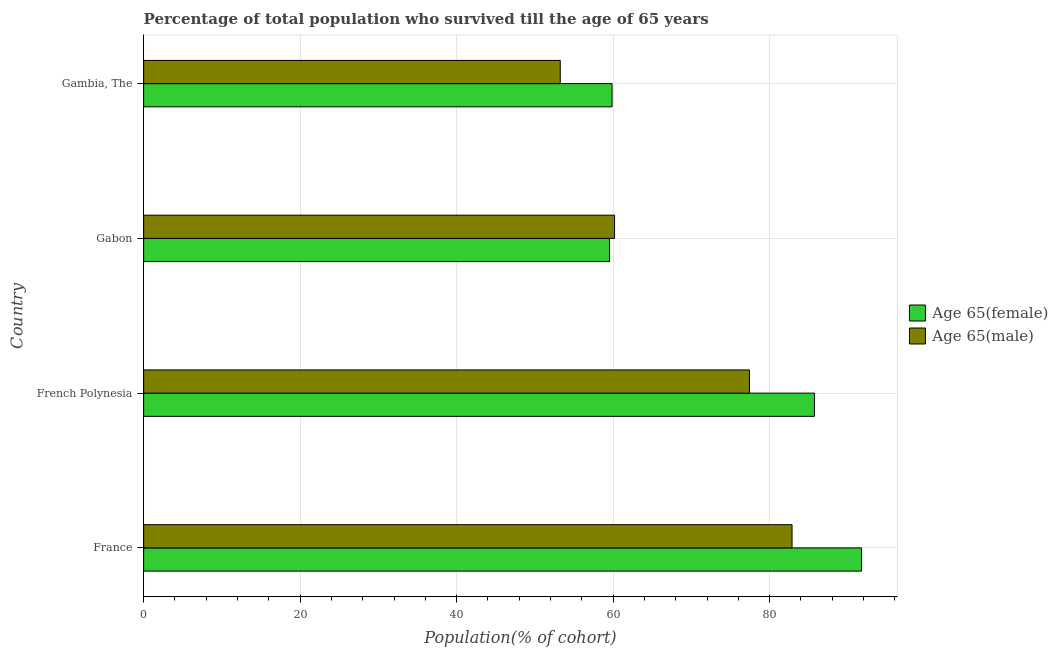How many different coloured bars are there?
Give a very brief answer. 2. How many groups of bars are there?
Your response must be concise. 4. Are the number of bars per tick equal to the number of legend labels?
Offer a terse response. Yes. Are the number of bars on each tick of the Y-axis equal?
Give a very brief answer. Yes. How many bars are there on the 3rd tick from the bottom?
Ensure brevity in your answer.  2. What is the label of the 4th group of bars from the top?
Provide a succinct answer. France. What is the percentage of female population who survived till age of 65 in France?
Make the answer very short. 91.74. Across all countries, what is the maximum percentage of male population who survived till age of 65?
Keep it short and to the point. 82.86. Across all countries, what is the minimum percentage of female population who survived till age of 65?
Provide a short and direct response. 59.54. In which country was the percentage of female population who survived till age of 65 minimum?
Provide a short and direct response. Gabon. What is the total percentage of male population who survived till age of 65 in the graph?
Offer a terse response. 273.71. What is the difference between the percentage of female population who survived till age of 65 in France and that in French Polynesia?
Offer a very short reply. 6.01. What is the difference between the percentage of female population who survived till age of 65 in Gabon and the percentage of male population who survived till age of 65 in France?
Offer a terse response. -23.33. What is the average percentage of male population who survived till age of 65 per country?
Your response must be concise. 68.43. What is the difference between the percentage of male population who survived till age of 65 and percentage of female population who survived till age of 65 in French Polynesia?
Give a very brief answer. -8.31. What is the ratio of the percentage of female population who survived till age of 65 in French Polynesia to that in Gabon?
Give a very brief answer. 1.44. Is the percentage of male population who survived till age of 65 in France less than that in French Polynesia?
Your response must be concise. No. What is the difference between the highest and the second highest percentage of female population who survived till age of 65?
Your answer should be very brief. 6.01. What is the difference between the highest and the lowest percentage of male population who survived till age of 65?
Give a very brief answer. 29.62. In how many countries, is the percentage of male population who survived till age of 65 greater than the average percentage of male population who survived till age of 65 taken over all countries?
Provide a short and direct response. 2. What does the 2nd bar from the top in Gabon represents?
Ensure brevity in your answer.  Age 65(female). What does the 2nd bar from the bottom in Gambia, The represents?
Offer a terse response. Age 65(male). Are all the bars in the graph horizontal?
Offer a very short reply. Yes. How many countries are there in the graph?
Give a very brief answer. 4. What is the difference between two consecutive major ticks on the X-axis?
Your response must be concise. 20. Are the values on the major ticks of X-axis written in scientific E-notation?
Offer a very short reply. No. Does the graph contain any zero values?
Provide a short and direct response. No. Does the graph contain grids?
Give a very brief answer. Yes. How many legend labels are there?
Offer a terse response. 2. What is the title of the graph?
Give a very brief answer. Percentage of total population who survived till the age of 65 years. Does "Old" appear as one of the legend labels in the graph?
Provide a short and direct response. No. What is the label or title of the X-axis?
Give a very brief answer. Population(% of cohort). What is the Population(% of cohort) in Age 65(female) in France?
Provide a short and direct response. 91.74. What is the Population(% of cohort) of Age 65(male) in France?
Your answer should be very brief. 82.86. What is the Population(% of cohort) in Age 65(female) in French Polynesia?
Keep it short and to the point. 85.73. What is the Population(% of cohort) in Age 65(male) in French Polynesia?
Ensure brevity in your answer.  77.42. What is the Population(% of cohort) of Age 65(female) in Gabon?
Provide a short and direct response. 59.54. What is the Population(% of cohort) of Age 65(male) in Gabon?
Provide a succinct answer. 60.18. What is the Population(% of cohort) of Age 65(female) in Gambia, The?
Provide a succinct answer. 59.86. What is the Population(% of cohort) of Age 65(male) in Gambia, The?
Make the answer very short. 53.24. Across all countries, what is the maximum Population(% of cohort) in Age 65(female)?
Offer a very short reply. 91.74. Across all countries, what is the maximum Population(% of cohort) in Age 65(male)?
Make the answer very short. 82.86. Across all countries, what is the minimum Population(% of cohort) in Age 65(female)?
Provide a succinct answer. 59.54. Across all countries, what is the minimum Population(% of cohort) in Age 65(male)?
Offer a terse response. 53.24. What is the total Population(% of cohort) of Age 65(female) in the graph?
Your answer should be very brief. 296.87. What is the total Population(% of cohort) of Age 65(male) in the graph?
Provide a short and direct response. 273.71. What is the difference between the Population(% of cohort) in Age 65(female) in France and that in French Polynesia?
Your answer should be very brief. 6.01. What is the difference between the Population(% of cohort) of Age 65(male) in France and that in French Polynesia?
Ensure brevity in your answer.  5.44. What is the difference between the Population(% of cohort) of Age 65(female) in France and that in Gabon?
Provide a short and direct response. 32.21. What is the difference between the Population(% of cohort) of Age 65(male) in France and that in Gabon?
Offer a very short reply. 22.68. What is the difference between the Population(% of cohort) in Age 65(female) in France and that in Gambia, The?
Offer a terse response. 31.88. What is the difference between the Population(% of cohort) of Age 65(male) in France and that in Gambia, The?
Provide a succinct answer. 29.62. What is the difference between the Population(% of cohort) of Age 65(female) in French Polynesia and that in Gabon?
Ensure brevity in your answer.  26.19. What is the difference between the Population(% of cohort) in Age 65(male) in French Polynesia and that in Gabon?
Give a very brief answer. 17.24. What is the difference between the Population(% of cohort) in Age 65(female) in French Polynesia and that in Gambia, The?
Provide a short and direct response. 25.87. What is the difference between the Population(% of cohort) in Age 65(male) in French Polynesia and that in Gambia, The?
Keep it short and to the point. 24.18. What is the difference between the Population(% of cohort) in Age 65(female) in Gabon and that in Gambia, The?
Provide a short and direct response. -0.32. What is the difference between the Population(% of cohort) of Age 65(male) in Gabon and that in Gambia, The?
Your response must be concise. 6.94. What is the difference between the Population(% of cohort) of Age 65(female) in France and the Population(% of cohort) of Age 65(male) in French Polynesia?
Your answer should be very brief. 14.32. What is the difference between the Population(% of cohort) of Age 65(female) in France and the Population(% of cohort) of Age 65(male) in Gabon?
Provide a short and direct response. 31.56. What is the difference between the Population(% of cohort) of Age 65(female) in France and the Population(% of cohort) of Age 65(male) in Gambia, The?
Your answer should be very brief. 38.5. What is the difference between the Population(% of cohort) in Age 65(female) in French Polynesia and the Population(% of cohort) in Age 65(male) in Gabon?
Keep it short and to the point. 25.55. What is the difference between the Population(% of cohort) of Age 65(female) in French Polynesia and the Population(% of cohort) of Age 65(male) in Gambia, The?
Keep it short and to the point. 32.49. What is the difference between the Population(% of cohort) of Age 65(female) in Gabon and the Population(% of cohort) of Age 65(male) in Gambia, The?
Ensure brevity in your answer.  6.3. What is the average Population(% of cohort) of Age 65(female) per country?
Your answer should be compact. 74.22. What is the average Population(% of cohort) in Age 65(male) per country?
Your answer should be compact. 68.43. What is the difference between the Population(% of cohort) in Age 65(female) and Population(% of cohort) in Age 65(male) in France?
Keep it short and to the point. 8.88. What is the difference between the Population(% of cohort) in Age 65(female) and Population(% of cohort) in Age 65(male) in French Polynesia?
Make the answer very short. 8.31. What is the difference between the Population(% of cohort) of Age 65(female) and Population(% of cohort) of Age 65(male) in Gabon?
Your response must be concise. -0.64. What is the difference between the Population(% of cohort) in Age 65(female) and Population(% of cohort) in Age 65(male) in Gambia, The?
Your answer should be compact. 6.62. What is the ratio of the Population(% of cohort) in Age 65(female) in France to that in French Polynesia?
Offer a terse response. 1.07. What is the ratio of the Population(% of cohort) in Age 65(male) in France to that in French Polynesia?
Give a very brief answer. 1.07. What is the ratio of the Population(% of cohort) in Age 65(female) in France to that in Gabon?
Give a very brief answer. 1.54. What is the ratio of the Population(% of cohort) in Age 65(male) in France to that in Gabon?
Offer a very short reply. 1.38. What is the ratio of the Population(% of cohort) of Age 65(female) in France to that in Gambia, The?
Provide a short and direct response. 1.53. What is the ratio of the Population(% of cohort) of Age 65(male) in France to that in Gambia, The?
Offer a terse response. 1.56. What is the ratio of the Population(% of cohort) in Age 65(female) in French Polynesia to that in Gabon?
Make the answer very short. 1.44. What is the ratio of the Population(% of cohort) of Age 65(male) in French Polynesia to that in Gabon?
Keep it short and to the point. 1.29. What is the ratio of the Population(% of cohort) in Age 65(female) in French Polynesia to that in Gambia, The?
Provide a succinct answer. 1.43. What is the ratio of the Population(% of cohort) of Age 65(male) in French Polynesia to that in Gambia, The?
Keep it short and to the point. 1.45. What is the ratio of the Population(% of cohort) of Age 65(female) in Gabon to that in Gambia, The?
Keep it short and to the point. 0.99. What is the ratio of the Population(% of cohort) of Age 65(male) in Gabon to that in Gambia, The?
Make the answer very short. 1.13. What is the difference between the highest and the second highest Population(% of cohort) of Age 65(female)?
Ensure brevity in your answer.  6.01. What is the difference between the highest and the second highest Population(% of cohort) in Age 65(male)?
Your response must be concise. 5.44. What is the difference between the highest and the lowest Population(% of cohort) of Age 65(female)?
Offer a terse response. 32.21. What is the difference between the highest and the lowest Population(% of cohort) in Age 65(male)?
Ensure brevity in your answer.  29.62. 